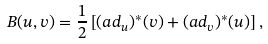<formula> <loc_0><loc_0><loc_500><loc_500>B ( u , v ) = \frac { 1 } { 2 } \left [ ( a d _ { u } ) ^ { * } ( v ) + ( a d _ { v } ) ^ { * } ( u ) \right ] ,</formula> 